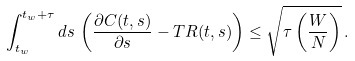<formula> <loc_0><loc_0><loc_500><loc_500>\int ^ { t _ { w } + \tau } _ { t _ { w } } d s \, \left ( \frac { \partial C ( t , s ) } { \partial s } - T R ( t , s ) \right ) \leq \sqrt { \tau \left ( \frac { W } { N } \right ) } \, .</formula> 